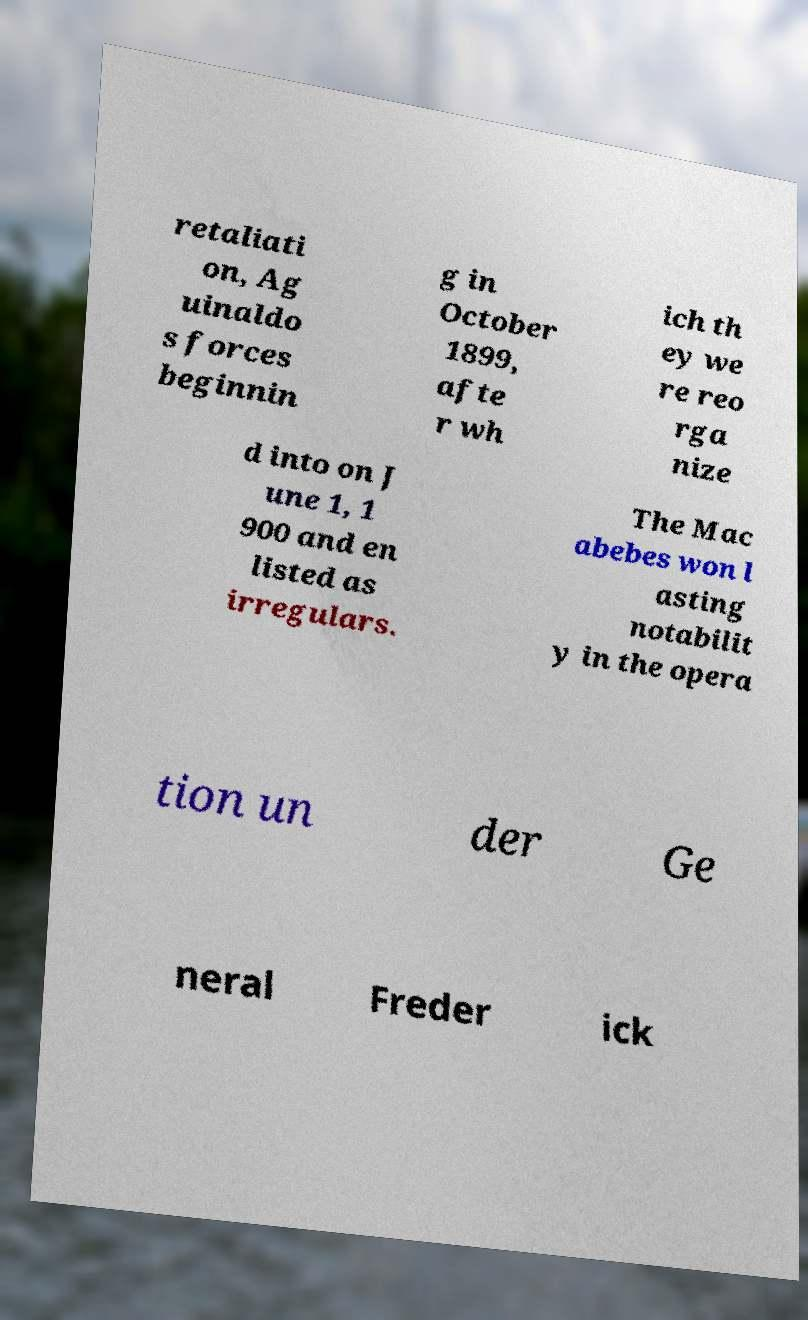Can you read and provide the text displayed in the image?This photo seems to have some interesting text. Can you extract and type it out for me? retaliati on, Ag uinaldo s forces beginnin g in October 1899, afte r wh ich th ey we re reo rga nize d into on J une 1, 1 900 and en listed as irregulars. The Mac abebes won l asting notabilit y in the opera tion un der Ge neral Freder ick 